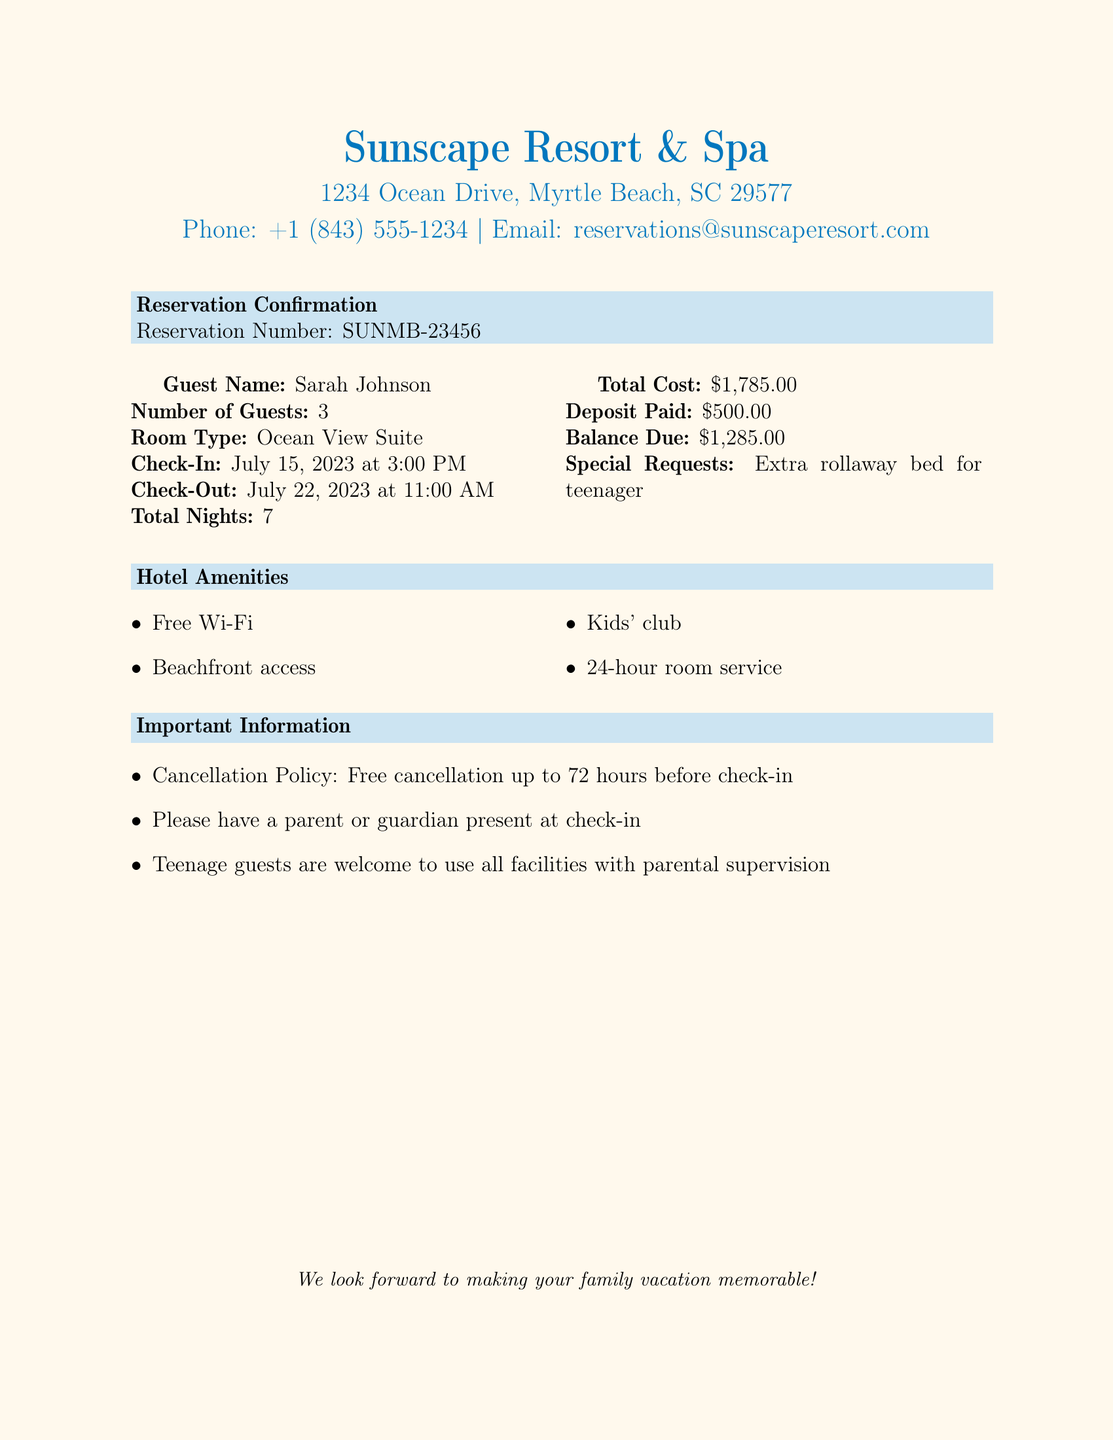What is the guest's name? The document lists the guest's name in the reservation details.
Answer: Sarah Johnson What is the room type? The room type is specified in the reservation details of the document.
Answer: Ocean View Suite How many nights is the stay? The total nights are clearly mentioned in the reservation details.
Answer: 7 What is the total cost? The total cost is provided in the financial summary of the reservation.
Answer: $1,785.00 What time is check-in? The check-in time is specified under the check-in information in the document.
Answer: 3:00 PM What is the balance due? The balance due is mentioned in the financial details of the reservation.
Answer: $1,285.00 When is the check-out date? The check-out date is specified in the reservation details section of the document.
Answer: July 22, 2023 What special request was made? The special request for the room is noted in the reservation details section.
Answer: Extra rollaway bed for teenager What is the cancellation policy? The cancellation policy is outlined in the important information section of the document.
Answer: Free cancellation up to 72 hours before check-in Are teenagers allowed to use facilities? The document mentions this in the important information section regarding teenage guests.
Answer: Yes, with parental supervision 